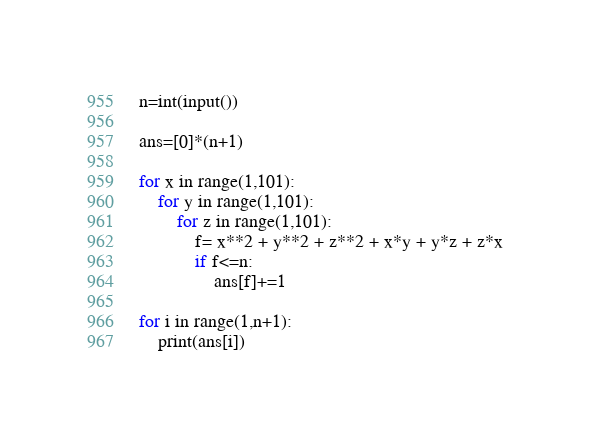Convert code to text. <code><loc_0><loc_0><loc_500><loc_500><_Python_>n=int(input())

ans=[0]*(n+1)

for x in range(1,101):
    for y in range(1,101):
        for z in range(1,101):
            f= x**2 + y**2 + z**2 + x*y + y*z + z*x
            if f<=n:
                ans[f]+=1

for i in range(1,n+1):
    print(ans[i])
</code> 